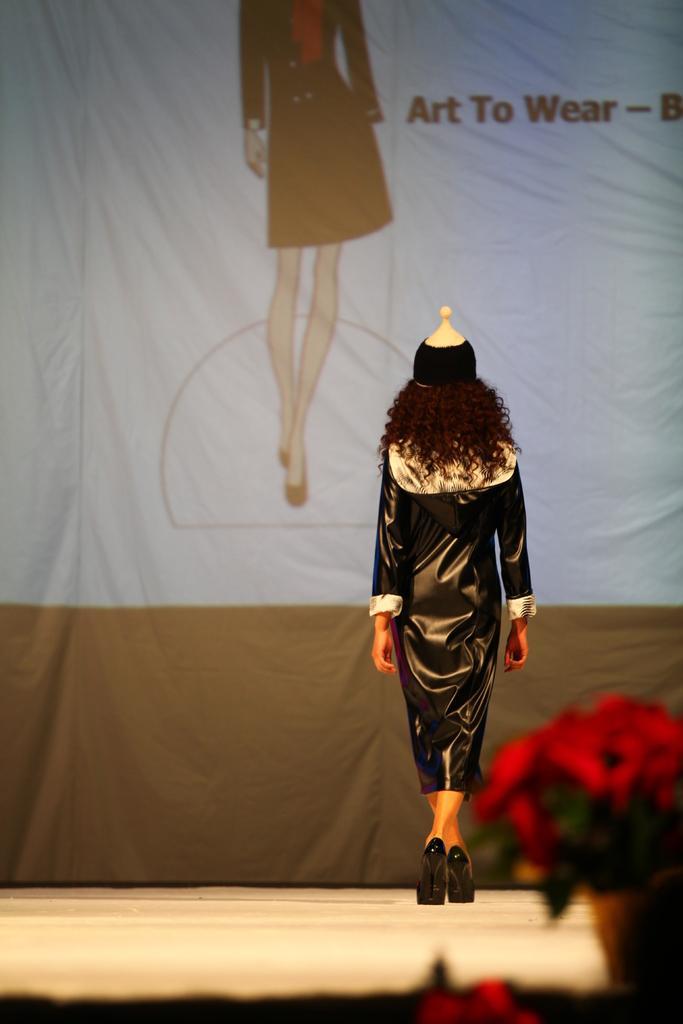In one or two sentences, can you explain what this image depicts? In this image I can see a person wearing black and cream colored dress is standing on the cream colored floor. I can see few flowers which are red in color. In the background I can see a huge banner. 